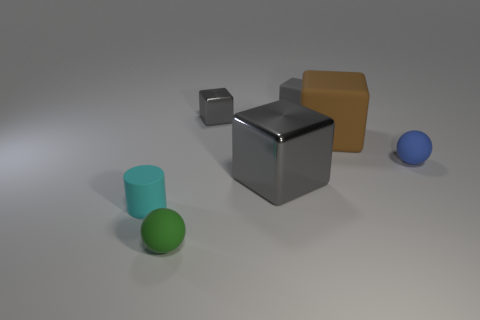How many gray cubes must be subtracted to get 1 gray cubes? 2 Add 2 purple metallic things. How many objects exist? 9 Subtract all gray blocks. How many blocks are left? 1 Subtract all red cylinders. How many gray cubes are left? 3 Subtract 1 cylinders. How many cylinders are left? 0 Subtract all gray blocks. How many blocks are left? 1 Subtract all cylinders. How many objects are left? 6 Subtract all gray spheres. Subtract all red blocks. How many spheres are left? 2 Subtract all blue balls. Subtract all green matte objects. How many objects are left? 5 Add 2 tiny matte cylinders. How many tiny matte cylinders are left? 3 